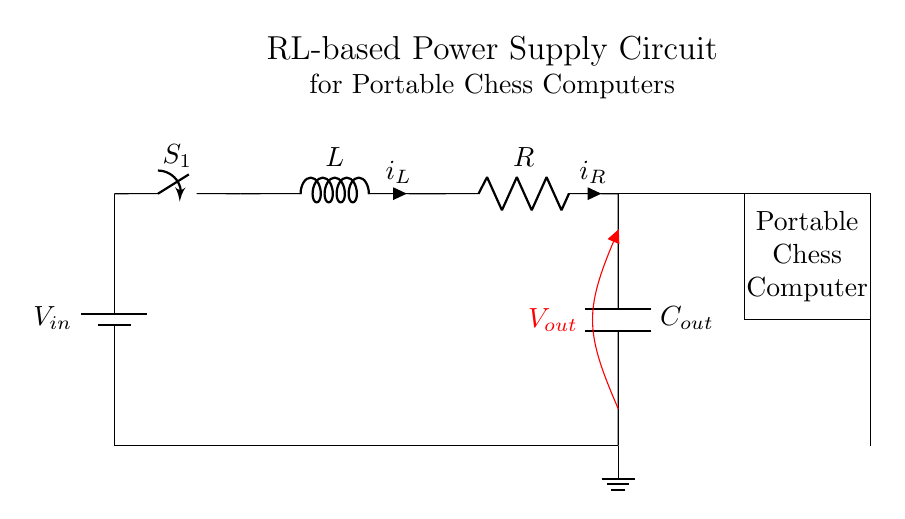what is the input voltage of this power supply circuit? The input voltage, depicted by \(V_{in}\), is the voltage supplied to the circuit. It is shown at the top of the circuit diagram connected to the battery.
Answer: \(V_{in}\) what is the component connected to node 4? The component connected to node 4 in the diagram is an inductor, represented by \(L\). It is the first component after the switch in the circuit.
Answer: \(L\) what is the role of the capacitor in this circuit? The capacitor, labeled \(C_{out}\), is used for filtering and smoothing the output voltage to ensure stable power supply to the load (the chess computer). This helps in reducing voltage fluctuations.
Answer: Smoothing how does current flow through the circuit after the switch is closed? When the switch is closed, current flows from the battery through the switch into the inductor, and then to the resistor before reaching the output capacitor and finally to the load. This series configuration allows current to pass sequentially through each component.
Answer: Series which component limits the current in the circuit? The resistor, labeled \(R\), limits the current flowing through the circuit as it creates resistance to the flow of electricity. It is crucial for protecting the components from excessive currents.
Answer: \(R\) what happens to the current when the inductor builds up a magnetic field? When the inductor builds up a magnetic field, it initially resists changes in current, causing a delay in the rise of current flow. This is due to the inductor's property of opposing changes in current, termed inductance.
Answer: Delays current how is the power delivered to the chess computer regulated? The power is regulated through the resistor and capacitor combination. The resistor controls the current, while the capacitor smooths out voltage variations, providing a stable voltage level to the chess computer.
Answer: Regulation through \(R\) and \(C_{out}\) 